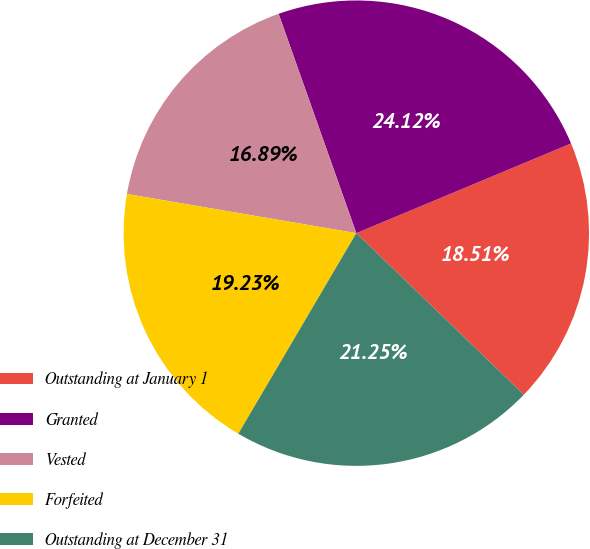Convert chart to OTSL. <chart><loc_0><loc_0><loc_500><loc_500><pie_chart><fcel>Outstanding at January 1<fcel>Granted<fcel>Vested<fcel>Forfeited<fcel>Outstanding at December 31<nl><fcel>18.51%<fcel>24.12%<fcel>16.89%<fcel>19.23%<fcel>21.25%<nl></chart> 